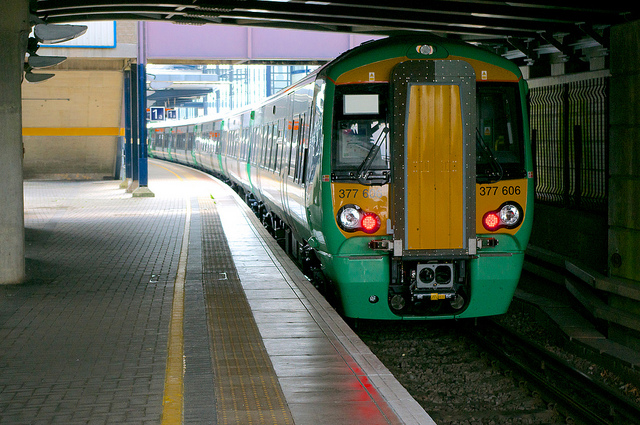Read all the text in this image. 377 6 377 606 1 